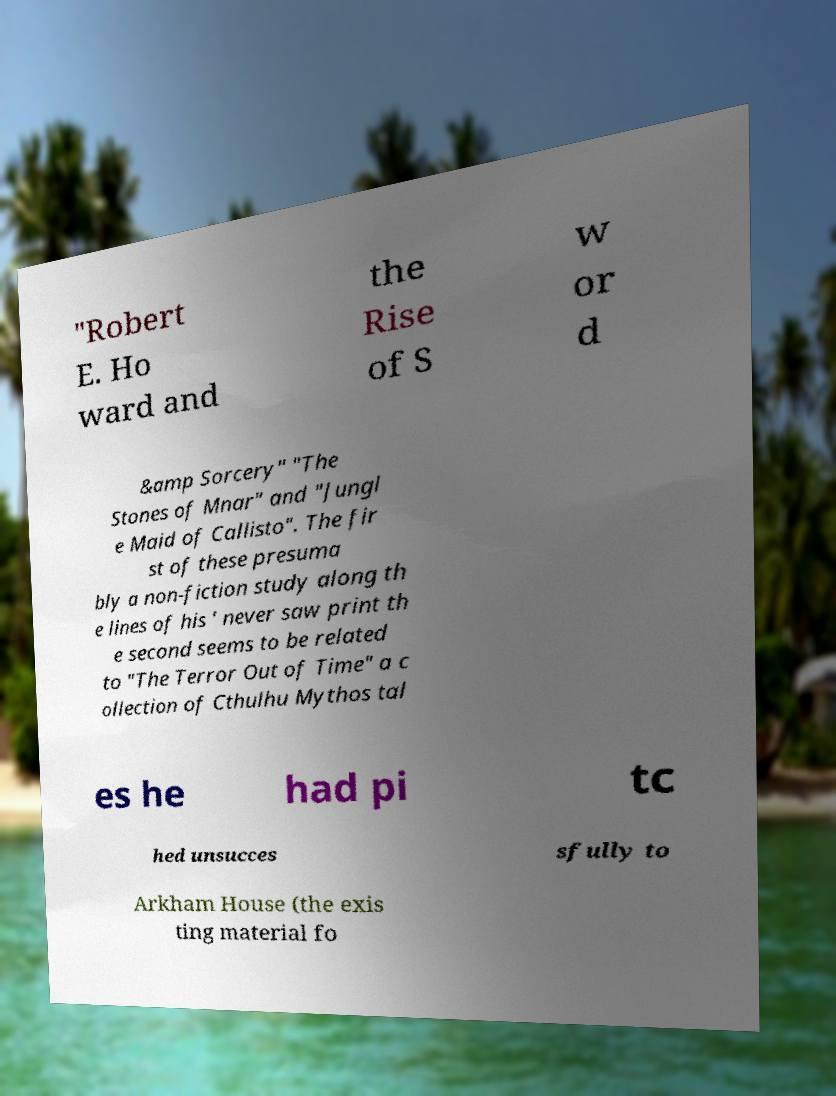What messages or text are displayed in this image? I need them in a readable, typed format. "Robert E. Ho ward and the Rise of S w or d &amp Sorcery" "The Stones of Mnar" and "Jungl e Maid of Callisto". The fir st of these presuma bly a non-fiction study along th e lines of his ' never saw print th e second seems to be related to "The Terror Out of Time" a c ollection of Cthulhu Mythos tal es he had pi tc hed unsucces sfully to Arkham House (the exis ting material fo 